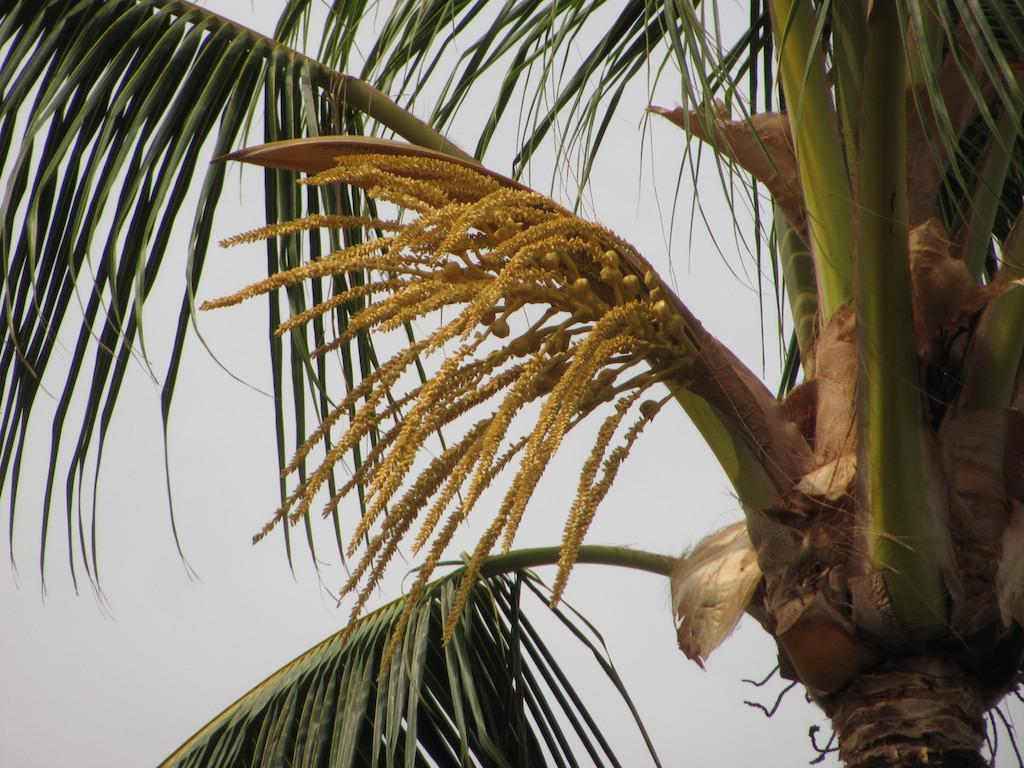What type of magic spell can be seen being cast in the jail at the airport in the image? There is no image provided, and therefore no such scene involving a magic spell, a jail, or an airport can be observed. What type of magic spell can be seen being cast in the jail at the airport in the image? There is no image provided, and therefore no such scene involving a magic spell, a jail, or an airport can be observed. 